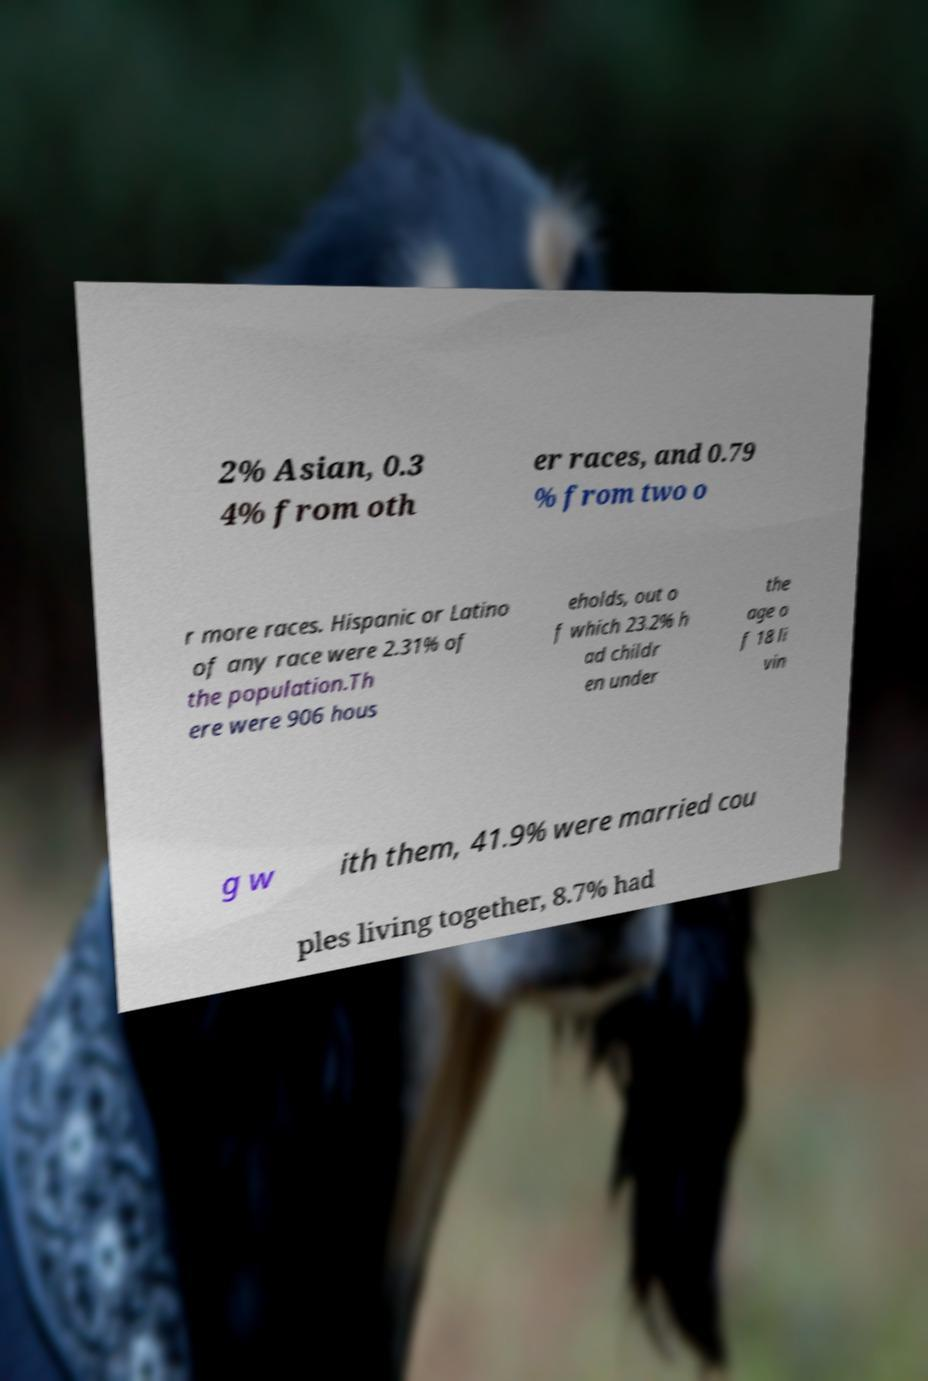Please read and relay the text visible in this image. What does it say? 2% Asian, 0.3 4% from oth er races, and 0.79 % from two o r more races. Hispanic or Latino of any race were 2.31% of the population.Th ere were 906 hous eholds, out o f which 23.2% h ad childr en under the age o f 18 li vin g w ith them, 41.9% were married cou ples living together, 8.7% had 